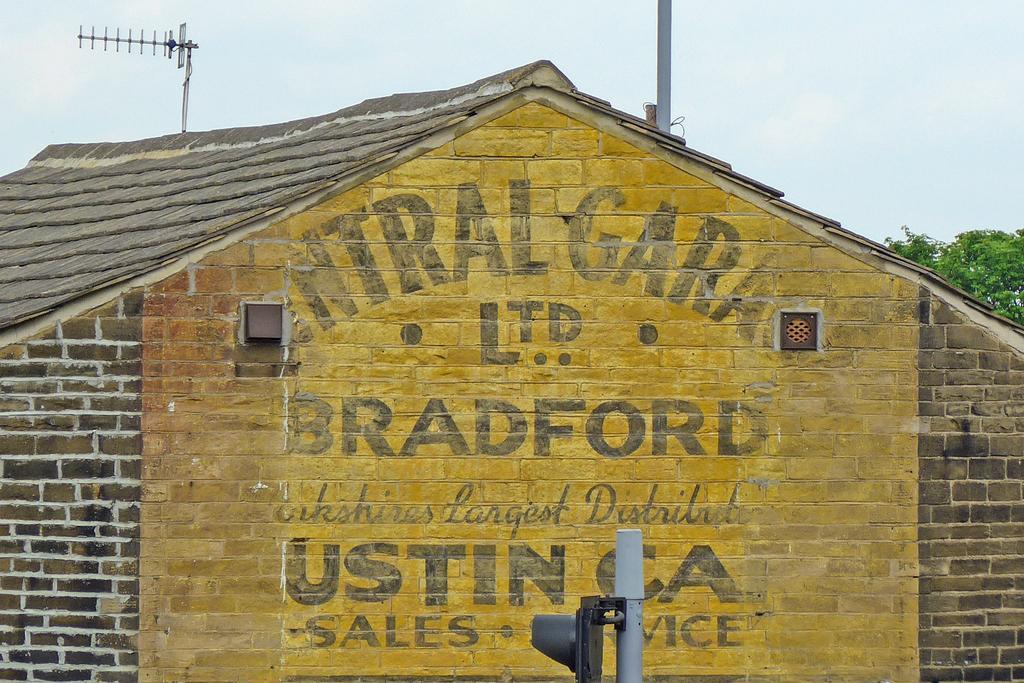In one or two sentences, can you explain what this image depicts? In this picture there is a brick wall which has some thing written on it and there is a traffic signal attached to a pole in front of it and there are two other poles above it and there is a tree in the right corner. 